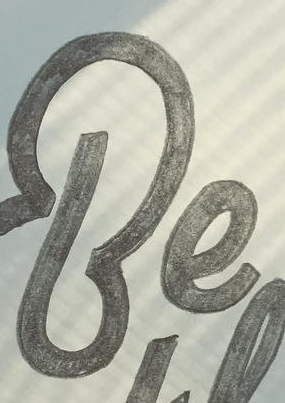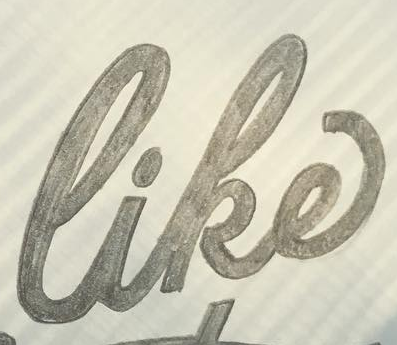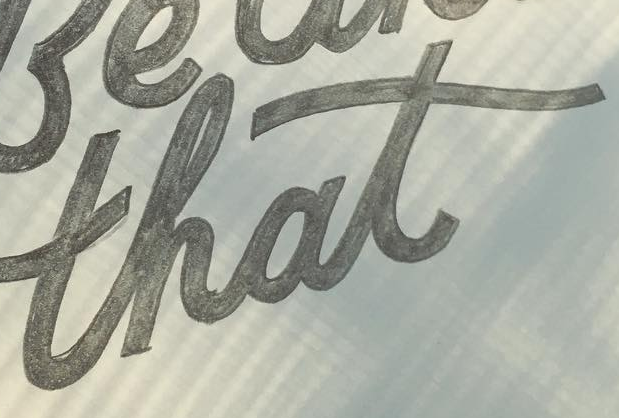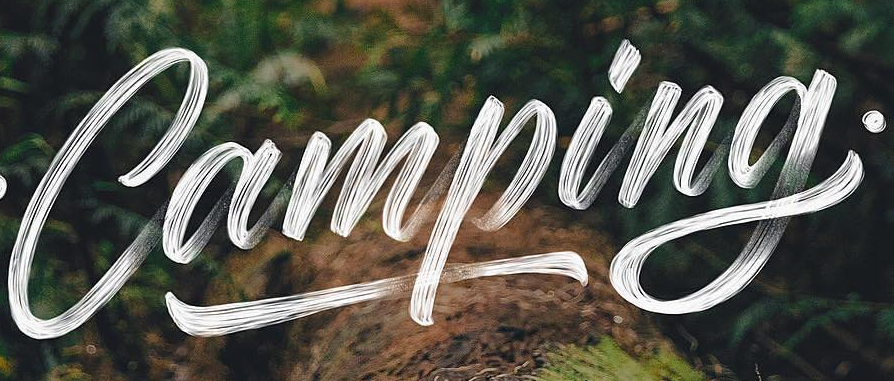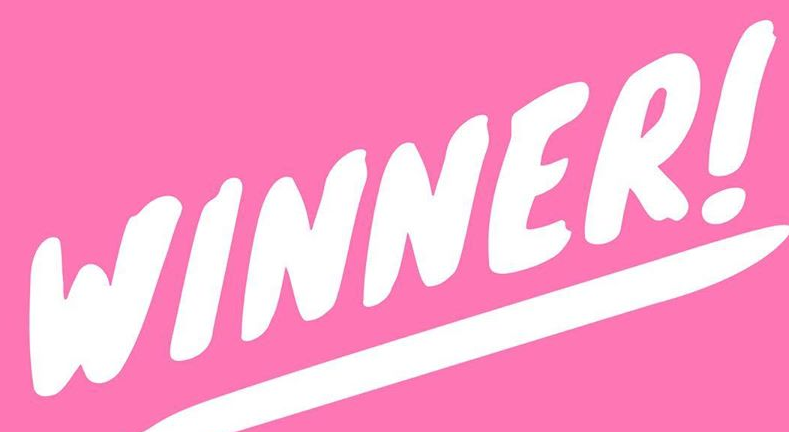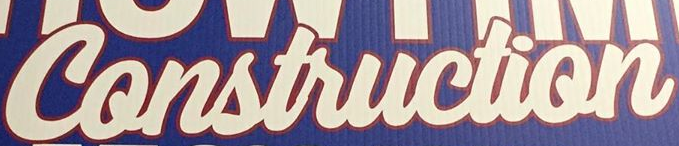What words are shown in these images in order, separated by a semicolon? Be; like; that; Camping; WINNER!; Construction 